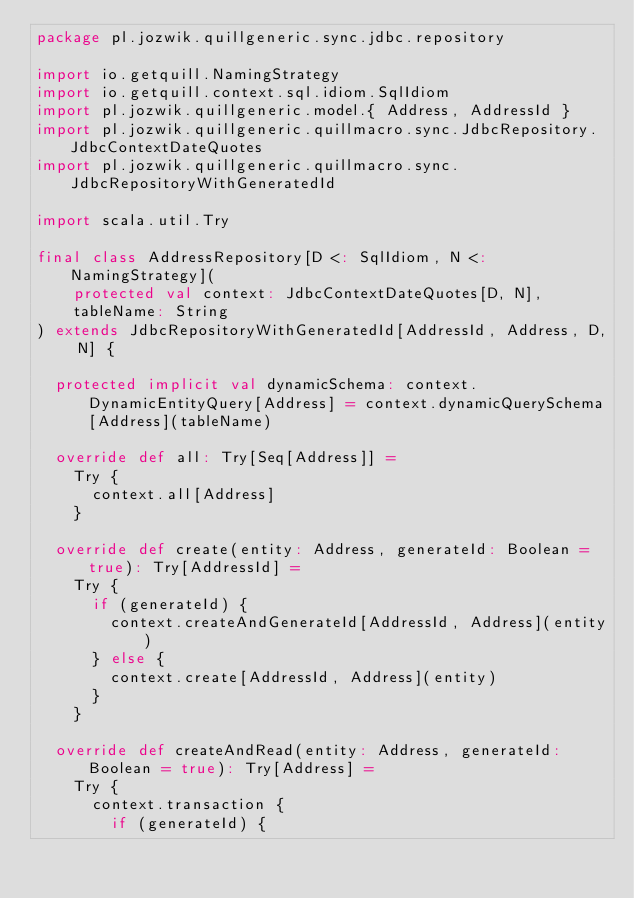<code> <loc_0><loc_0><loc_500><loc_500><_Scala_>package pl.jozwik.quillgeneric.sync.jdbc.repository

import io.getquill.NamingStrategy
import io.getquill.context.sql.idiom.SqlIdiom
import pl.jozwik.quillgeneric.model.{ Address, AddressId }
import pl.jozwik.quillgeneric.quillmacro.sync.JdbcRepository.JdbcContextDateQuotes
import pl.jozwik.quillgeneric.quillmacro.sync.JdbcRepositoryWithGeneratedId

import scala.util.Try

final class AddressRepository[D <: SqlIdiom, N <: NamingStrategy](
    protected val context: JdbcContextDateQuotes[D, N],
    tableName: String
) extends JdbcRepositoryWithGeneratedId[AddressId, Address, D, N] {

  protected implicit val dynamicSchema: context.DynamicEntityQuery[Address] = context.dynamicQuerySchema[Address](tableName)

  override def all: Try[Seq[Address]] =
    Try {
      context.all[Address]
    }

  override def create(entity: Address, generateId: Boolean = true): Try[AddressId] =
    Try {
      if (generateId) {
        context.createAndGenerateId[AddressId, Address](entity)
      } else {
        context.create[AddressId, Address](entity)
      }
    }

  override def createAndRead(entity: Address, generateId: Boolean = true): Try[Address] =
    Try {
      context.transaction {
        if (generateId) {</code> 